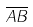Convert formula to latex. <formula><loc_0><loc_0><loc_500><loc_500>\overline { A B }</formula> 